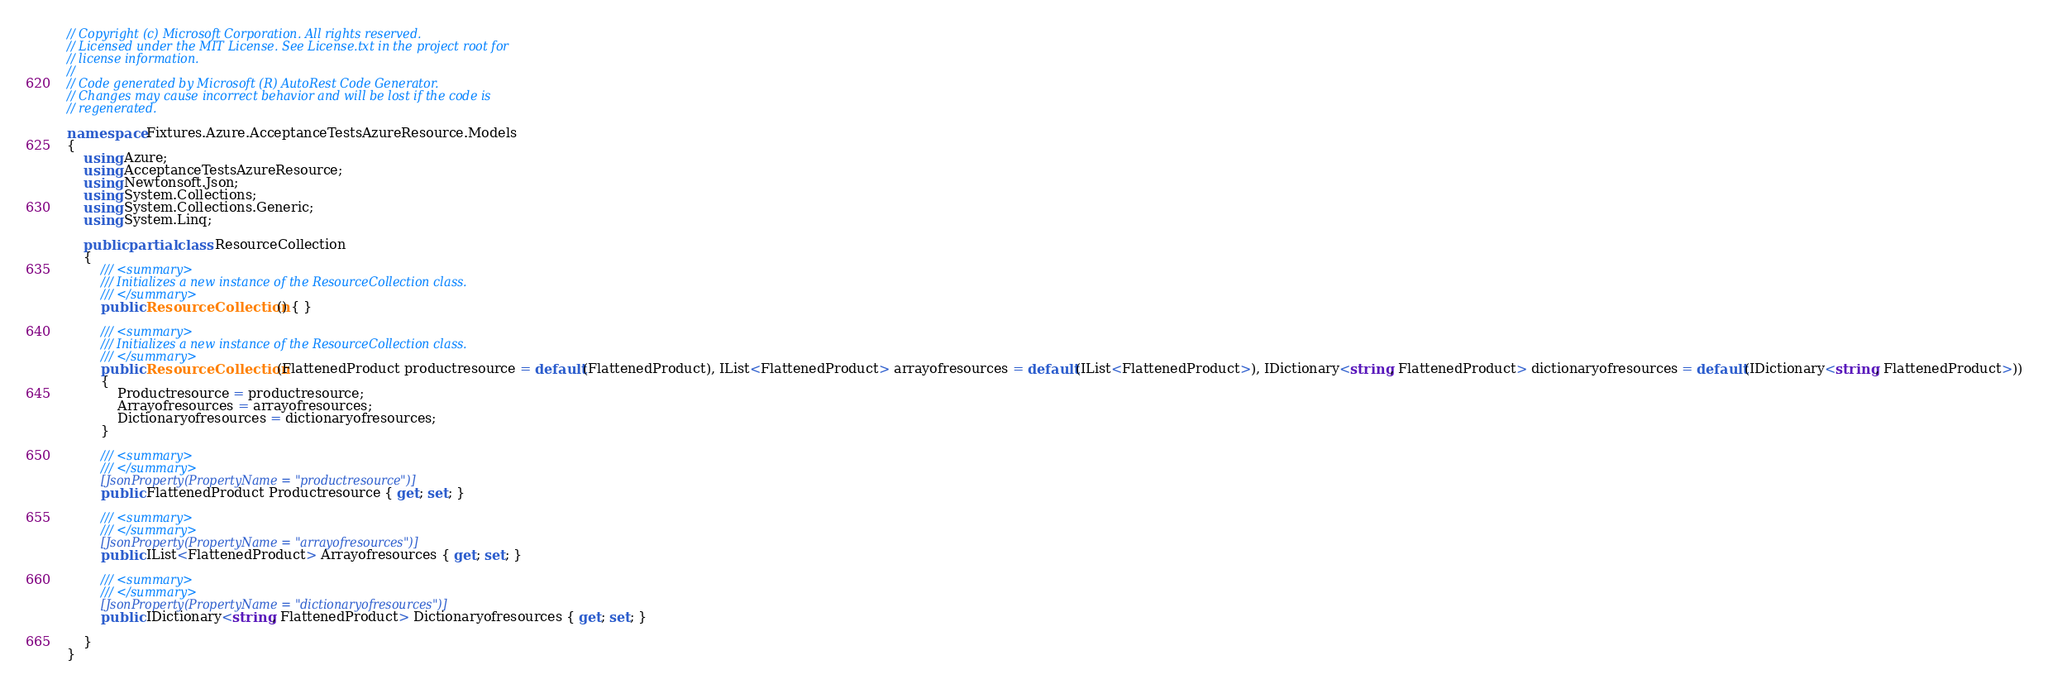<code> <loc_0><loc_0><loc_500><loc_500><_C#_>// Copyright (c) Microsoft Corporation. All rights reserved.
// Licensed under the MIT License. See License.txt in the project root for
// license information.
//
// Code generated by Microsoft (R) AutoRest Code Generator.
// Changes may cause incorrect behavior and will be lost if the code is
// regenerated.

namespace Fixtures.Azure.AcceptanceTestsAzureResource.Models
{
    using Azure;
    using AcceptanceTestsAzureResource;
    using Newtonsoft.Json;
    using System.Collections;
    using System.Collections.Generic;
    using System.Linq;

    public partial class ResourceCollection
    {
        /// <summary>
        /// Initializes a new instance of the ResourceCollection class.
        /// </summary>
        public ResourceCollection() { }

        /// <summary>
        /// Initializes a new instance of the ResourceCollection class.
        /// </summary>
        public ResourceCollection(FlattenedProduct productresource = default(FlattenedProduct), IList<FlattenedProduct> arrayofresources = default(IList<FlattenedProduct>), IDictionary<string, FlattenedProduct> dictionaryofresources = default(IDictionary<string, FlattenedProduct>))
        {
            Productresource = productresource;
            Arrayofresources = arrayofresources;
            Dictionaryofresources = dictionaryofresources;
        }

        /// <summary>
        /// </summary>
        [JsonProperty(PropertyName = "productresource")]
        public FlattenedProduct Productresource { get; set; }

        /// <summary>
        /// </summary>
        [JsonProperty(PropertyName = "arrayofresources")]
        public IList<FlattenedProduct> Arrayofresources { get; set; }

        /// <summary>
        /// </summary>
        [JsonProperty(PropertyName = "dictionaryofresources")]
        public IDictionary<string, FlattenedProduct> Dictionaryofresources { get; set; }

    }
}

</code> 